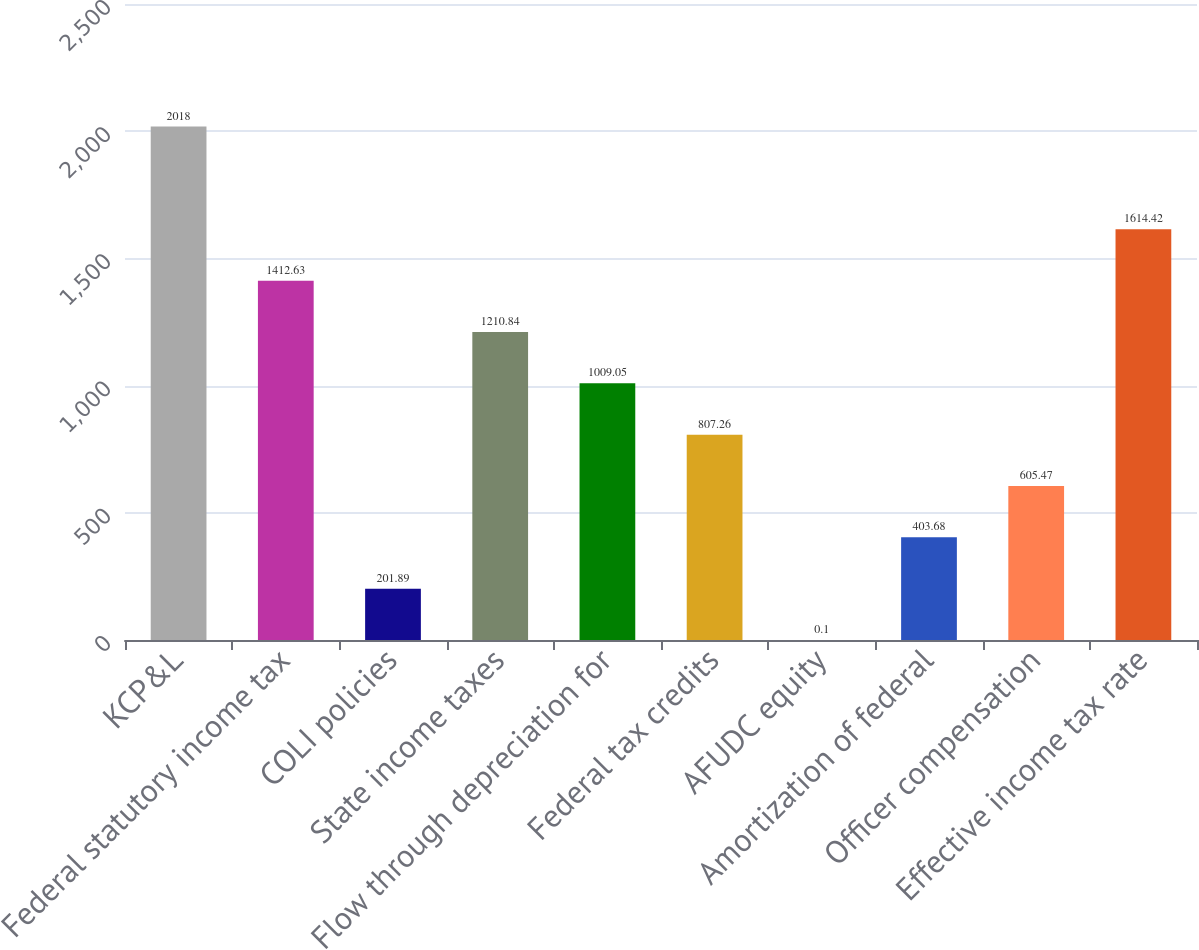Convert chart. <chart><loc_0><loc_0><loc_500><loc_500><bar_chart><fcel>KCP&L<fcel>Federal statutory income tax<fcel>COLI policies<fcel>State income taxes<fcel>Flow through depreciation for<fcel>Federal tax credits<fcel>AFUDC equity<fcel>Amortization of federal<fcel>Officer compensation<fcel>Effective income tax rate<nl><fcel>2018<fcel>1412.63<fcel>201.89<fcel>1210.84<fcel>1009.05<fcel>807.26<fcel>0.1<fcel>403.68<fcel>605.47<fcel>1614.42<nl></chart> 